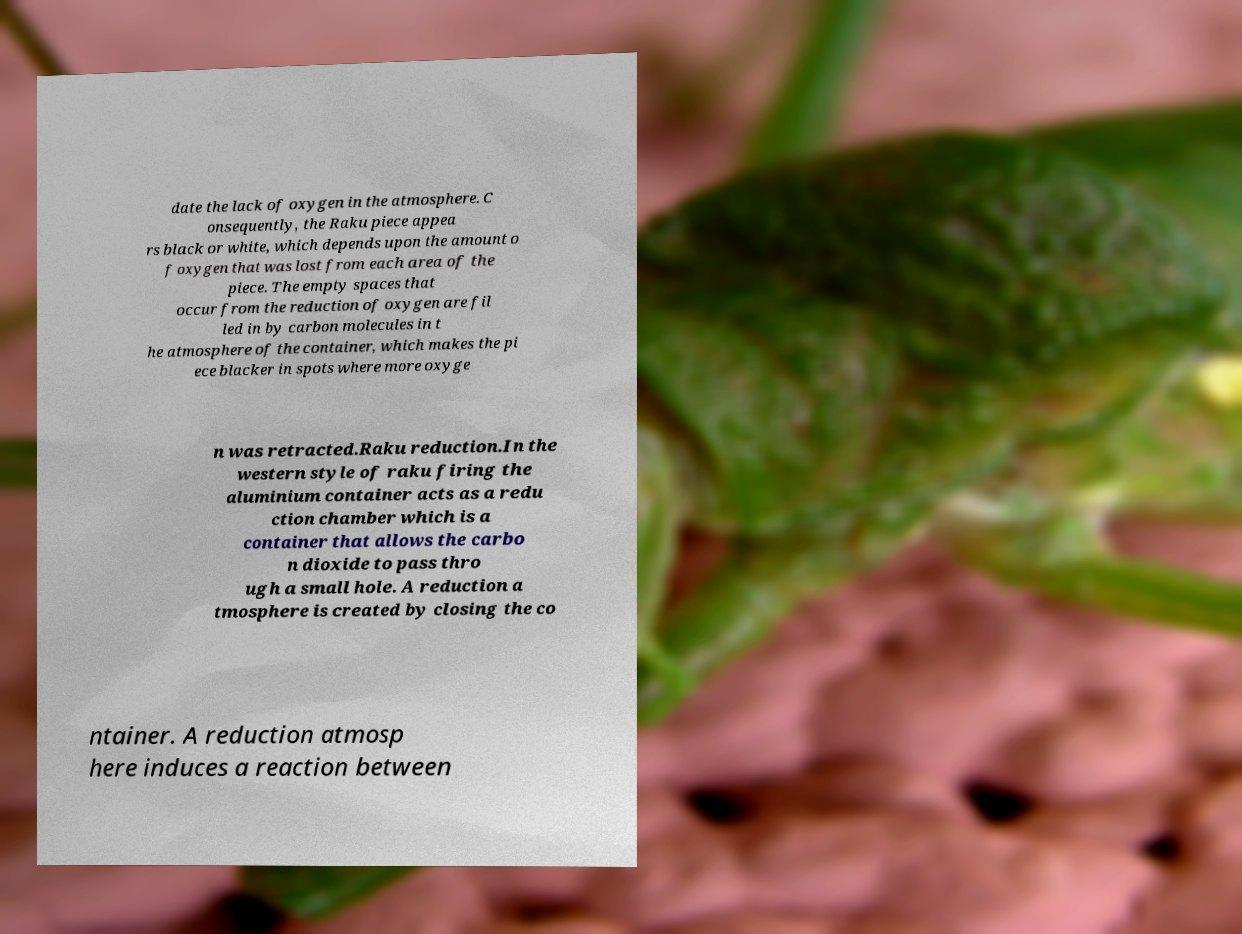Could you extract and type out the text from this image? date the lack of oxygen in the atmosphere. C onsequently, the Raku piece appea rs black or white, which depends upon the amount o f oxygen that was lost from each area of the piece. The empty spaces that occur from the reduction of oxygen are fil led in by carbon molecules in t he atmosphere of the container, which makes the pi ece blacker in spots where more oxyge n was retracted.Raku reduction.In the western style of raku firing the aluminium container acts as a redu ction chamber which is a container that allows the carbo n dioxide to pass thro ugh a small hole. A reduction a tmosphere is created by closing the co ntainer. A reduction atmosp here induces a reaction between 